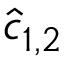Convert formula to latex. <formula><loc_0><loc_0><loc_500><loc_500>\hat { c } _ { 1 , 2 }</formula> 